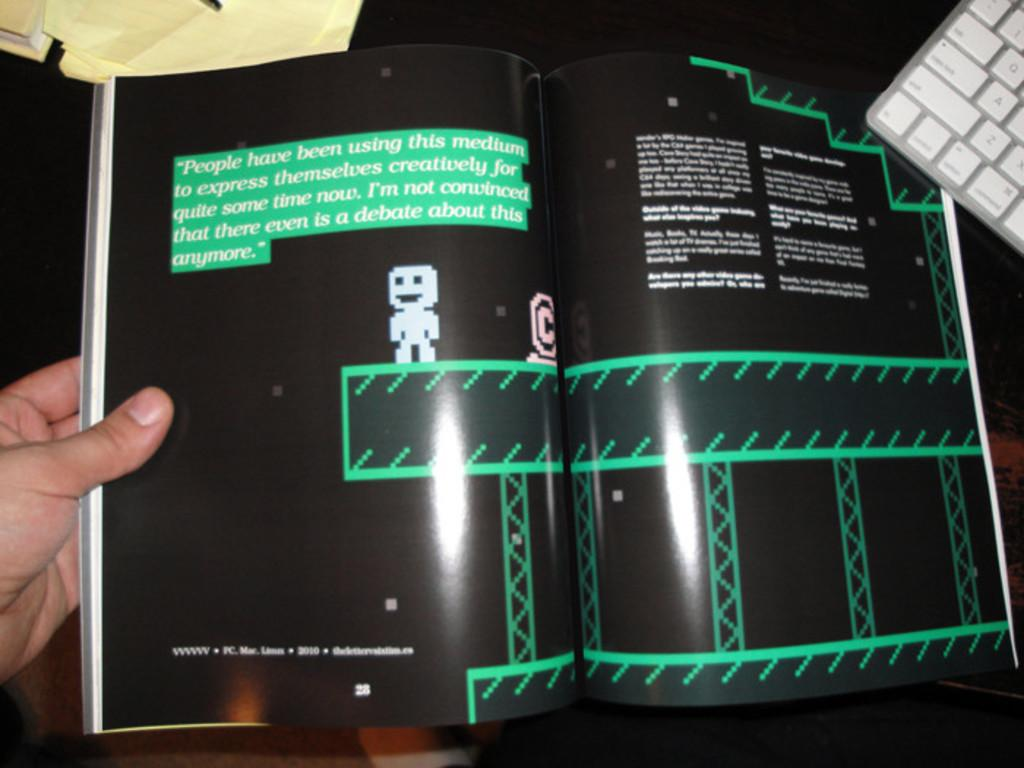<image>
Write a terse but informative summary of the picture. Person holding a book that is currently on page 28. 